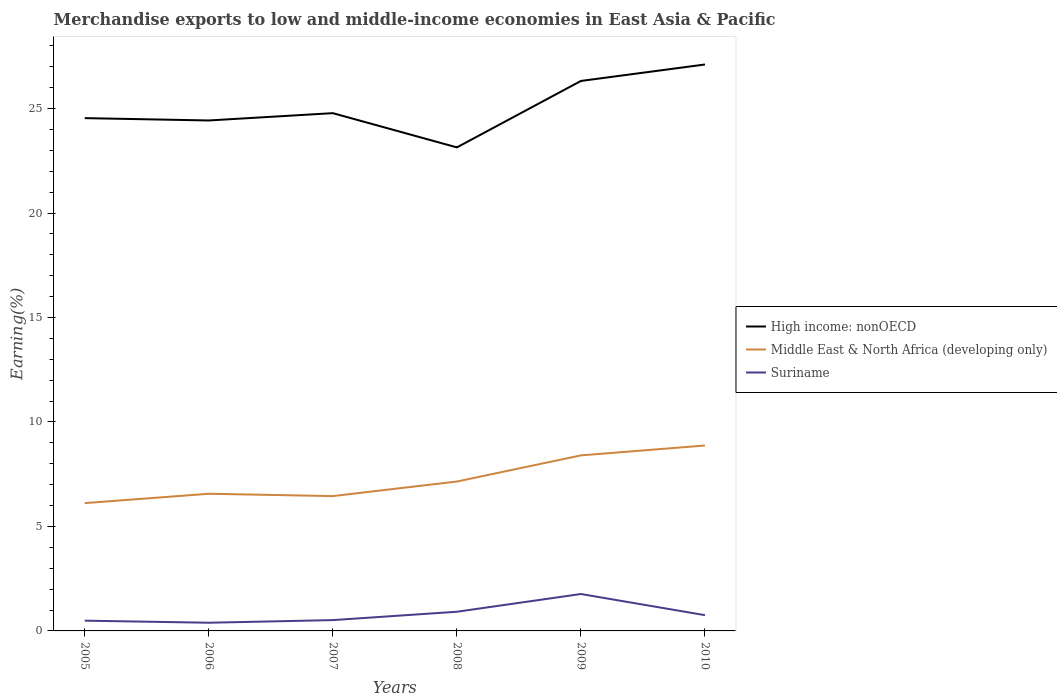Is the number of lines equal to the number of legend labels?
Your answer should be very brief. Yes. Across all years, what is the maximum percentage of amount earned from merchandise exports in High income: nonOECD?
Provide a short and direct response. 23.14. In which year was the percentage of amount earned from merchandise exports in Suriname maximum?
Offer a very short reply. 2006. What is the total percentage of amount earned from merchandise exports in Suriname in the graph?
Offer a terse response. 0.1. What is the difference between the highest and the second highest percentage of amount earned from merchandise exports in Middle East & North Africa (developing only)?
Keep it short and to the point. 2.76. What is the difference between the highest and the lowest percentage of amount earned from merchandise exports in Middle East & North Africa (developing only)?
Make the answer very short. 2. Is the percentage of amount earned from merchandise exports in Suriname strictly greater than the percentage of amount earned from merchandise exports in Middle East & North Africa (developing only) over the years?
Provide a succinct answer. Yes. How many lines are there?
Your answer should be compact. 3. What is the difference between two consecutive major ticks on the Y-axis?
Your response must be concise. 5. How many legend labels are there?
Give a very brief answer. 3. How are the legend labels stacked?
Keep it short and to the point. Vertical. What is the title of the graph?
Your response must be concise. Merchandise exports to low and middle-income economies in East Asia & Pacific. What is the label or title of the Y-axis?
Make the answer very short. Earning(%). What is the Earning(%) in High income: nonOECD in 2005?
Your response must be concise. 24.54. What is the Earning(%) in Middle East & North Africa (developing only) in 2005?
Give a very brief answer. 6.12. What is the Earning(%) of Suriname in 2005?
Your answer should be very brief. 0.49. What is the Earning(%) of High income: nonOECD in 2006?
Keep it short and to the point. 24.43. What is the Earning(%) in Middle East & North Africa (developing only) in 2006?
Your answer should be compact. 6.56. What is the Earning(%) in Suriname in 2006?
Give a very brief answer. 0.39. What is the Earning(%) in High income: nonOECD in 2007?
Your response must be concise. 24.78. What is the Earning(%) of Middle East & North Africa (developing only) in 2007?
Give a very brief answer. 6.45. What is the Earning(%) in Suriname in 2007?
Provide a succinct answer. 0.52. What is the Earning(%) of High income: nonOECD in 2008?
Provide a succinct answer. 23.14. What is the Earning(%) in Middle East & North Africa (developing only) in 2008?
Ensure brevity in your answer.  7.15. What is the Earning(%) in Suriname in 2008?
Keep it short and to the point. 0.92. What is the Earning(%) in High income: nonOECD in 2009?
Provide a short and direct response. 26.32. What is the Earning(%) in Middle East & North Africa (developing only) in 2009?
Your response must be concise. 8.4. What is the Earning(%) in Suriname in 2009?
Provide a short and direct response. 1.77. What is the Earning(%) of High income: nonOECD in 2010?
Your answer should be compact. 27.11. What is the Earning(%) in Middle East & North Africa (developing only) in 2010?
Your answer should be compact. 8.87. What is the Earning(%) of Suriname in 2010?
Keep it short and to the point. 0.75. Across all years, what is the maximum Earning(%) of High income: nonOECD?
Give a very brief answer. 27.11. Across all years, what is the maximum Earning(%) of Middle East & North Africa (developing only)?
Your response must be concise. 8.87. Across all years, what is the maximum Earning(%) in Suriname?
Offer a very short reply. 1.77. Across all years, what is the minimum Earning(%) of High income: nonOECD?
Keep it short and to the point. 23.14. Across all years, what is the minimum Earning(%) of Middle East & North Africa (developing only)?
Offer a terse response. 6.12. Across all years, what is the minimum Earning(%) of Suriname?
Ensure brevity in your answer.  0.39. What is the total Earning(%) in High income: nonOECD in the graph?
Provide a short and direct response. 150.33. What is the total Earning(%) in Middle East & North Africa (developing only) in the graph?
Ensure brevity in your answer.  43.56. What is the total Earning(%) in Suriname in the graph?
Offer a very short reply. 4.84. What is the difference between the Earning(%) of High income: nonOECD in 2005 and that in 2006?
Provide a succinct answer. 0.11. What is the difference between the Earning(%) in Middle East & North Africa (developing only) in 2005 and that in 2006?
Provide a succinct answer. -0.45. What is the difference between the Earning(%) in Suriname in 2005 and that in 2006?
Your response must be concise. 0.1. What is the difference between the Earning(%) in High income: nonOECD in 2005 and that in 2007?
Keep it short and to the point. -0.24. What is the difference between the Earning(%) in Middle East & North Africa (developing only) in 2005 and that in 2007?
Ensure brevity in your answer.  -0.34. What is the difference between the Earning(%) of Suriname in 2005 and that in 2007?
Provide a succinct answer. -0.03. What is the difference between the Earning(%) in High income: nonOECD in 2005 and that in 2008?
Make the answer very short. 1.4. What is the difference between the Earning(%) of Middle East & North Africa (developing only) in 2005 and that in 2008?
Make the answer very short. -1.03. What is the difference between the Earning(%) of Suriname in 2005 and that in 2008?
Your response must be concise. -0.43. What is the difference between the Earning(%) of High income: nonOECD in 2005 and that in 2009?
Your answer should be compact. -1.78. What is the difference between the Earning(%) in Middle East & North Africa (developing only) in 2005 and that in 2009?
Keep it short and to the point. -2.28. What is the difference between the Earning(%) in Suriname in 2005 and that in 2009?
Keep it short and to the point. -1.28. What is the difference between the Earning(%) of High income: nonOECD in 2005 and that in 2010?
Your answer should be very brief. -2.57. What is the difference between the Earning(%) in Middle East & North Africa (developing only) in 2005 and that in 2010?
Provide a succinct answer. -2.76. What is the difference between the Earning(%) in Suriname in 2005 and that in 2010?
Make the answer very short. -0.26. What is the difference between the Earning(%) of High income: nonOECD in 2006 and that in 2007?
Make the answer very short. -0.35. What is the difference between the Earning(%) in Middle East & North Africa (developing only) in 2006 and that in 2007?
Ensure brevity in your answer.  0.11. What is the difference between the Earning(%) in Suriname in 2006 and that in 2007?
Keep it short and to the point. -0.13. What is the difference between the Earning(%) in High income: nonOECD in 2006 and that in 2008?
Provide a short and direct response. 1.29. What is the difference between the Earning(%) in Middle East & North Africa (developing only) in 2006 and that in 2008?
Provide a succinct answer. -0.59. What is the difference between the Earning(%) of Suriname in 2006 and that in 2008?
Keep it short and to the point. -0.53. What is the difference between the Earning(%) of High income: nonOECD in 2006 and that in 2009?
Provide a short and direct response. -1.89. What is the difference between the Earning(%) of Middle East & North Africa (developing only) in 2006 and that in 2009?
Your answer should be compact. -1.84. What is the difference between the Earning(%) of Suriname in 2006 and that in 2009?
Keep it short and to the point. -1.38. What is the difference between the Earning(%) of High income: nonOECD in 2006 and that in 2010?
Keep it short and to the point. -2.68. What is the difference between the Earning(%) of Middle East & North Africa (developing only) in 2006 and that in 2010?
Your response must be concise. -2.31. What is the difference between the Earning(%) in Suriname in 2006 and that in 2010?
Your response must be concise. -0.36. What is the difference between the Earning(%) in High income: nonOECD in 2007 and that in 2008?
Ensure brevity in your answer.  1.64. What is the difference between the Earning(%) of Middle East & North Africa (developing only) in 2007 and that in 2008?
Offer a terse response. -0.7. What is the difference between the Earning(%) in Suriname in 2007 and that in 2008?
Offer a very short reply. -0.4. What is the difference between the Earning(%) in High income: nonOECD in 2007 and that in 2009?
Your response must be concise. -1.54. What is the difference between the Earning(%) of Middle East & North Africa (developing only) in 2007 and that in 2009?
Your answer should be compact. -1.95. What is the difference between the Earning(%) of Suriname in 2007 and that in 2009?
Keep it short and to the point. -1.25. What is the difference between the Earning(%) of High income: nonOECD in 2007 and that in 2010?
Make the answer very short. -2.33. What is the difference between the Earning(%) in Middle East & North Africa (developing only) in 2007 and that in 2010?
Provide a succinct answer. -2.42. What is the difference between the Earning(%) in Suriname in 2007 and that in 2010?
Keep it short and to the point. -0.24. What is the difference between the Earning(%) of High income: nonOECD in 2008 and that in 2009?
Make the answer very short. -3.18. What is the difference between the Earning(%) in Middle East & North Africa (developing only) in 2008 and that in 2009?
Your answer should be compact. -1.25. What is the difference between the Earning(%) in Suriname in 2008 and that in 2009?
Offer a terse response. -0.85. What is the difference between the Earning(%) of High income: nonOECD in 2008 and that in 2010?
Give a very brief answer. -3.97. What is the difference between the Earning(%) in Middle East & North Africa (developing only) in 2008 and that in 2010?
Your answer should be compact. -1.72. What is the difference between the Earning(%) of Suriname in 2008 and that in 2010?
Provide a short and direct response. 0.16. What is the difference between the Earning(%) of High income: nonOECD in 2009 and that in 2010?
Make the answer very short. -0.79. What is the difference between the Earning(%) of Middle East & North Africa (developing only) in 2009 and that in 2010?
Provide a short and direct response. -0.47. What is the difference between the Earning(%) of Suriname in 2009 and that in 2010?
Provide a short and direct response. 1.01. What is the difference between the Earning(%) in High income: nonOECD in 2005 and the Earning(%) in Middle East & North Africa (developing only) in 2006?
Make the answer very short. 17.98. What is the difference between the Earning(%) in High income: nonOECD in 2005 and the Earning(%) in Suriname in 2006?
Your answer should be compact. 24.15. What is the difference between the Earning(%) in Middle East & North Africa (developing only) in 2005 and the Earning(%) in Suriname in 2006?
Make the answer very short. 5.73. What is the difference between the Earning(%) in High income: nonOECD in 2005 and the Earning(%) in Middle East & North Africa (developing only) in 2007?
Keep it short and to the point. 18.09. What is the difference between the Earning(%) of High income: nonOECD in 2005 and the Earning(%) of Suriname in 2007?
Provide a short and direct response. 24.03. What is the difference between the Earning(%) in Middle East & North Africa (developing only) in 2005 and the Earning(%) in Suriname in 2007?
Provide a succinct answer. 5.6. What is the difference between the Earning(%) of High income: nonOECD in 2005 and the Earning(%) of Middle East & North Africa (developing only) in 2008?
Make the answer very short. 17.39. What is the difference between the Earning(%) of High income: nonOECD in 2005 and the Earning(%) of Suriname in 2008?
Offer a terse response. 23.63. What is the difference between the Earning(%) in Middle East & North Africa (developing only) in 2005 and the Earning(%) in Suriname in 2008?
Ensure brevity in your answer.  5.2. What is the difference between the Earning(%) of High income: nonOECD in 2005 and the Earning(%) of Middle East & North Africa (developing only) in 2009?
Your answer should be compact. 16.14. What is the difference between the Earning(%) in High income: nonOECD in 2005 and the Earning(%) in Suriname in 2009?
Provide a succinct answer. 22.78. What is the difference between the Earning(%) in Middle East & North Africa (developing only) in 2005 and the Earning(%) in Suriname in 2009?
Provide a succinct answer. 4.35. What is the difference between the Earning(%) of High income: nonOECD in 2005 and the Earning(%) of Middle East & North Africa (developing only) in 2010?
Ensure brevity in your answer.  15.67. What is the difference between the Earning(%) of High income: nonOECD in 2005 and the Earning(%) of Suriname in 2010?
Provide a short and direct response. 23.79. What is the difference between the Earning(%) of Middle East & North Africa (developing only) in 2005 and the Earning(%) of Suriname in 2010?
Offer a very short reply. 5.36. What is the difference between the Earning(%) of High income: nonOECD in 2006 and the Earning(%) of Middle East & North Africa (developing only) in 2007?
Your answer should be very brief. 17.98. What is the difference between the Earning(%) in High income: nonOECD in 2006 and the Earning(%) in Suriname in 2007?
Provide a short and direct response. 23.91. What is the difference between the Earning(%) in Middle East & North Africa (developing only) in 2006 and the Earning(%) in Suriname in 2007?
Ensure brevity in your answer.  6.05. What is the difference between the Earning(%) of High income: nonOECD in 2006 and the Earning(%) of Middle East & North Africa (developing only) in 2008?
Give a very brief answer. 17.28. What is the difference between the Earning(%) in High income: nonOECD in 2006 and the Earning(%) in Suriname in 2008?
Offer a terse response. 23.51. What is the difference between the Earning(%) in Middle East & North Africa (developing only) in 2006 and the Earning(%) in Suriname in 2008?
Provide a short and direct response. 5.65. What is the difference between the Earning(%) of High income: nonOECD in 2006 and the Earning(%) of Middle East & North Africa (developing only) in 2009?
Give a very brief answer. 16.03. What is the difference between the Earning(%) of High income: nonOECD in 2006 and the Earning(%) of Suriname in 2009?
Offer a terse response. 22.66. What is the difference between the Earning(%) of Middle East & North Africa (developing only) in 2006 and the Earning(%) of Suriname in 2009?
Provide a succinct answer. 4.8. What is the difference between the Earning(%) in High income: nonOECD in 2006 and the Earning(%) in Middle East & North Africa (developing only) in 2010?
Ensure brevity in your answer.  15.56. What is the difference between the Earning(%) of High income: nonOECD in 2006 and the Earning(%) of Suriname in 2010?
Make the answer very short. 23.68. What is the difference between the Earning(%) of Middle East & North Africa (developing only) in 2006 and the Earning(%) of Suriname in 2010?
Provide a succinct answer. 5.81. What is the difference between the Earning(%) of High income: nonOECD in 2007 and the Earning(%) of Middle East & North Africa (developing only) in 2008?
Offer a very short reply. 17.63. What is the difference between the Earning(%) in High income: nonOECD in 2007 and the Earning(%) in Suriname in 2008?
Make the answer very short. 23.86. What is the difference between the Earning(%) of Middle East & North Africa (developing only) in 2007 and the Earning(%) of Suriname in 2008?
Ensure brevity in your answer.  5.54. What is the difference between the Earning(%) of High income: nonOECD in 2007 and the Earning(%) of Middle East & North Africa (developing only) in 2009?
Provide a short and direct response. 16.38. What is the difference between the Earning(%) in High income: nonOECD in 2007 and the Earning(%) in Suriname in 2009?
Keep it short and to the point. 23.01. What is the difference between the Earning(%) of Middle East & North Africa (developing only) in 2007 and the Earning(%) of Suriname in 2009?
Give a very brief answer. 4.69. What is the difference between the Earning(%) of High income: nonOECD in 2007 and the Earning(%) of Middle East & North Africa (developing only) in 2010?
Ensure brevity in your answer.  15.91. What is the difference between the Earning(%) of High income: nonOECD in 2007 and the Earning(%) of Suriname in 2010?
Your answer should be compact. 24.03. What is the difference between the Earning(%) in Middle East & North Africa (developing only) in 2007 and the Earning(%) in Suriname in 2010?
Your response must be concise. 5.7. What is the difference between the Earning(%) of High income: nonOECD in 2008 and the Earning(%) of Middle East & North Africa (developing only) in 2009?
Keep it short and to the point. 14.74. What is the difference between the Earning(%) in High income: nonOECD in 2008 and the Earning(%) in Suriname in 2009?
Offer a very short reply. 21.38. What is the difference between the Earning(%) of Middle East & North Africa (developing only) in 2008 and the Earning(%) of Suriname in 2009?
Your answer should be very brief. 5.38. What is the difference between the Earning(%) of High income: nonOECD in 2008 and the Earning(%) of Middle East & North Africa (developing only) in 2010?
Provide a short and direct response. 14.27. What is the difference between the Earning(%) in High income: nonOECD in 2008 and the Earning(%) in Suriname in 2010?
Your response must be concise. 22.39. What is the difference between the Earning(%) in Middle East & North Africa (developing only) in 2008 and the Earning(%) in Suriname in 2010?
Keep it short and to the point. 6.4. What is the difference between the Earning(%) of High income: nonOECD in 2009 and the Earning(%) of Middle East & North Africa (developing only) in 2010?
Ensure brevity in your answer.  17.45. What is the difference between the Earning(%) of High income: nonOECD in 2009 and the Earning(%) of Suriname in 2010?
Your answer should be compact. 25.57. What is the difference between the Earning(%) of Middle East & North Africa (developing only) in 2009 and the Earning(%) of Suriname in 2010?
Make the answer very short. 7.65. What is the average Earning(%) in High income: nonOECD per year?
Make the answer very short. 25.06. What is the average Earning(%) in Middle East & North Africa (developing only) per year?
Offer a terse response. 7.26. What is the average Earning(%) of Suriname per year?
Offer a very short reply. 0.81. In the year 2005, what is the difference between the Earning(%) in High income: nonOECD and Earning(%) in Middle East & North Africa (developing only)?
Give a very brief answer. 18.43. In the year 2005, what is the difference between the Earning(%) of High income: nonOECD and Earning(%) of Suriname?
Offer a terse response. 24.05. In the year 2005, what is the difference between the Earning(%) in Middle East & North Africa (developing only) and Earning(%) in Suriname?
Provide a succinct answer. 5.63. In the year 2006, what is the difference between the Earning(%) of High income: nonOECD and Earning(%) of Middle East & North Africa (developing only)?
Your answer should be compact. 17.87. In the year 2006, what is the difference between the Earning(%) in High income: nonOECD and Earning(%) in Suriname?
Ensure brevity in your answer.  24.04. In the year 2006, what is the difference between the Earning(%) in Middle East & North Africa (developing only) and Earning(%) in Suriname?
Make the answer very short. 6.17. In the year 2007, what is the difference between the Earning(%) of High income: nonOECD and Earning(%) of Middle East & North Africa (developing only)?
Offer a very short reply. 18.33. In the year 2007, what is the difference between the Earning(%) of High income: nonOECD and Earning(%) of Suriname?
Give a very brief answer. 24.26. In the year 2007, what is the difference between the Earning(%) of Middle East & North Africa (developing only) and Earning(%) of Suriname?
Provide a succinct answer. 5.94. In the year 2008, what is the difference between the Earning(%) of High income: nonOECD and Earning(%) of Middle East & North Africa (developing only)?
Provide a short and direct response. 15.99. In the year 2008, what is the difference between the Earning(%) in High income: nonOECD and Earning(%) in Suriname?
Provide a short and direct response. 22.22. In the year 2008, what is the difference between the Earning(%) in Middle East & North Africa (developing only) and Earning(%) in Suriname?
Keep it short and to the point. 6.23. In the year 2009, what is the difference between the Earning(%) in High income: nonOECD and Earning(%) in Middle East & North Africa (developing only)?
Provide a short and direct response. 17.92. In the year 2009, what is the difference between the Earning(%) of High income: nonOECD and Earning(%) of Suriname?
Your answer should be very brief. 24.56. In the year 2009, what is the difference between the Earning(%) in Middle East & North Africa (developing only) and Earning(%) in Suriname?
Ensure brevity in your answer.  6.63. In the year 2010, what is the difference between the Earning(%) in High income: nonOECD and Earning(%) in Middle East & North Africa (developing only)?
Provide a short and direct response. 18.24. In the year 2010, what is the difference between the Earning(%) in High income: nonOECD and Earning(%) in Suriname?
Provide a succinct answer. 26.36. In the year 2010, what is the difference between the Earning(%) in Middle East & North Africa (developing only) and Earning(%) in Suriname?
Keep it short and to the point. 8.12. What is the ratio of the Earning(%) of Middle East & North Africa (developing only) in 2005 to that in 2006?
Your answer should be compact. 0.93. What is the ratio of the Earning(%) in Suriname in 2005 to that in 2006?
Keep it short and to the point. 1.25. What is the ratio of the Earning(%) of High income: nonOECD in 2005 to that in 2007?
Make the answer very short. 0.99. What is the ratio of the Earning(%) in Middle East & North Africa (developing only) in 2005 to that in 2007?
Provide a succinct answer. 0.95. What is the ratio of the Earning(%) in Suriname in 2005 to that in 2007?
Your answer should be compact. 0.95. What is the ratio of the Earning(%) of High income: nonOECD in 2005 to that in 2008?
Your answer should be very brief. 1.06. What is the ratio of the Earning(%) in Middle East & North Africa (developing only) in 2005 to that in 2008?
Offer a very short reply. 0.86. What is the ratio of the Earning(%) of Suriname in 2005 to that in 2008?
Your response must be concise. 0.54. What is the ratio of the Earning(%) of High income: nonOECD in 2005 to that in 2009?
Give a very brief answer. 0.93. What is the ratio of the Earning(%) in Middle East & North Africa (developing only) in 2005 to that in 2009?
Your answer should be very brief. 0.73. What is the ratio of the Earning(%) in Suriname in 2005 to that in 2009?
Give a very brief answer. 0.28. What is the ratio of the Earning(%) in High income: nonOECD in 2005 to that in 2010?
Offer a very short reply. 0.91. What is the ratio of the Earning(%) of Middle East & North Africa (developing only) in 2005 to that in 2010?
Provide a short and direct response. 0.69. What is the ratio of the Earning(%) in Suriname in 2005 to that in 2010?
Provide a succinct answer. 0.65. What is the ratio of the Earning(%) of High income: nonOECD in 2006 to that in 2007?
Your answer should be very brief. 0.99. What is the ratio of the Earning(%) in Middle East & North Africa (developing only) in 2006 to that in 2007?
Offer a terse response. 1.02. What is the ratio of the Earning(%) in Suriname in 2006 to that in 2007?
Your answer should be compact. 0.76. What is the ratio of the Earning(%) of High income: nonOECD in 2006 to that in 2008?
Your answer should be compact. 1.06. What is the ratio of the Earning(%) in Middle East & North Africa (developing only) in 2006 to that in 2008?
Your answer should be very brief. 0.92. What is the ratio of the Earning(%) in Suriname in 2006 to that in 2008?
Keep it short and to the point. 0.43. What is the ratio of the Earning(%) of High income: nonOECD in 2006 to that in 2009?
Keep it short and to the point. 0.93. What is the ratio of the Earning(%) in Middle East & North Africa (developing only) in 2006 to that in 2009?
Make the answer very short. 0.78. What is the ratio of the Earning(%) in Suriname in 2006 to that in 2009?
Provide a succinct answer. 0.22. What is the ratio of the Earning(%) in High income: nonOECD in 2006 to that in 2010?
Your answer should be very brief. 0.9. What is the ratio of the Earning(%) of Middle East & North Africa (developing only) in 2006 to that in 2010?
Ensure brevity in your answer.  0.74. What is the ratio of the Earning(%) in Suriname in 2006 to that in 2010?
Offer a very short reply. 0.52. What is the ratio of the Earning(%) in High income: nonOECD in 2007 to that in 2008?
Provide a succinct answer. 1.07. What is the ratio of the Earning(%) in Middle East & North Africa (developing only) in 2007 to that in 2008?
Offer a very short reply. 0.9. What is the ratio of the Earning(%) of Suriname in 2007 to that in 2008?
Offer a terse response. 0.56. What is the ratio of the Earning(%) of High income: nonOECD in 2007 to that in 2009?
Offer a terse response. 0.94. What is the ratio of the Earning(%) in Middle East & North Africa (developing only) in 2007 to that in 2009?
Give a very brief answer. 0.77. What is the ratio of the Earning(%) of Suriname in 2007 to that in 2009?
Your response must be concise. 0.29. What is the ratio of the Earning(%) of High income: nonOECD in 2007 to that in 2010?
Your answer should be compact. 0.91. What is the ratio of the Earning(%) of Middle East & North Africa (developing only) in 2007 to that in 2010?
Give a very brief answer. 0.73. What is the ratio of the Earning(%) in Suriname in 2007 to that in 2010?
Provide a short and direct response. 0.69. What is the ratio of the Earning(%) of High income: nonOECD in 2008 to that in 2009?
Offer a terse response. 0.88. What is the ratio of the Earning(%) of Middle East & North Africa (developing only) in 2008 to that in 2009?
Your answer should be compact. 0.85. What is the ratio of the Earning(%) of Suriname in 2008 to that in 2009?
Provide a succinct answer. 0.52. What is the ratio of the Earning(%) of High income: nonOECD in 2008 to that in 2010?
Your response must be concise. 0.85. What is the ratio of the Earning(%) of Middle East & North Africa (developing only) in 2008 to that in 2010?
Give a very brief answer. 0.81. What is the ratio of the Earning(%) in Suriname in 2008 to that in 2010?
Your answer should be very brief. 1.22. What is the ratio of the Earning(%) in High income: nonOECD in 2009 to that in 2010?
Your answer should be very brief. 0.97. What is the ratio of the Earning(%) in Middle East & North Africa (developing only) in 2009 to that in 2010?
Your response must be concise. 0.95. What is the ratio of the Earning(%) in Suriname in 2009 to that in 2010?
Your response must be concise. 2.34. What is the difference between the highest and the second highest Earning(%) of High income: nonOECD?
Provide a short and direct response. 0.79. What is the difference between the highest and the second highest Earning(%) in Middle East & North Africa (developing only)?
Provide a succinct answer. 0.47. What is the difference between the highest and the second highest Earning(%) in Suriname?
Provide a succinct answer. 0.85. What is the difference between the highest and the lowest Earning(%) in High income: nonOECD?
Offer a terse response. 3.97. What is the difference between the highest and the lowest Earning(%) of Middle East & North Africa (developing only)?
Your answer should be compact. 2.76. What is the difference between the highest and the lowest Earning(%) of Suriname?
Ensure brevity in your answer.  1.38. 